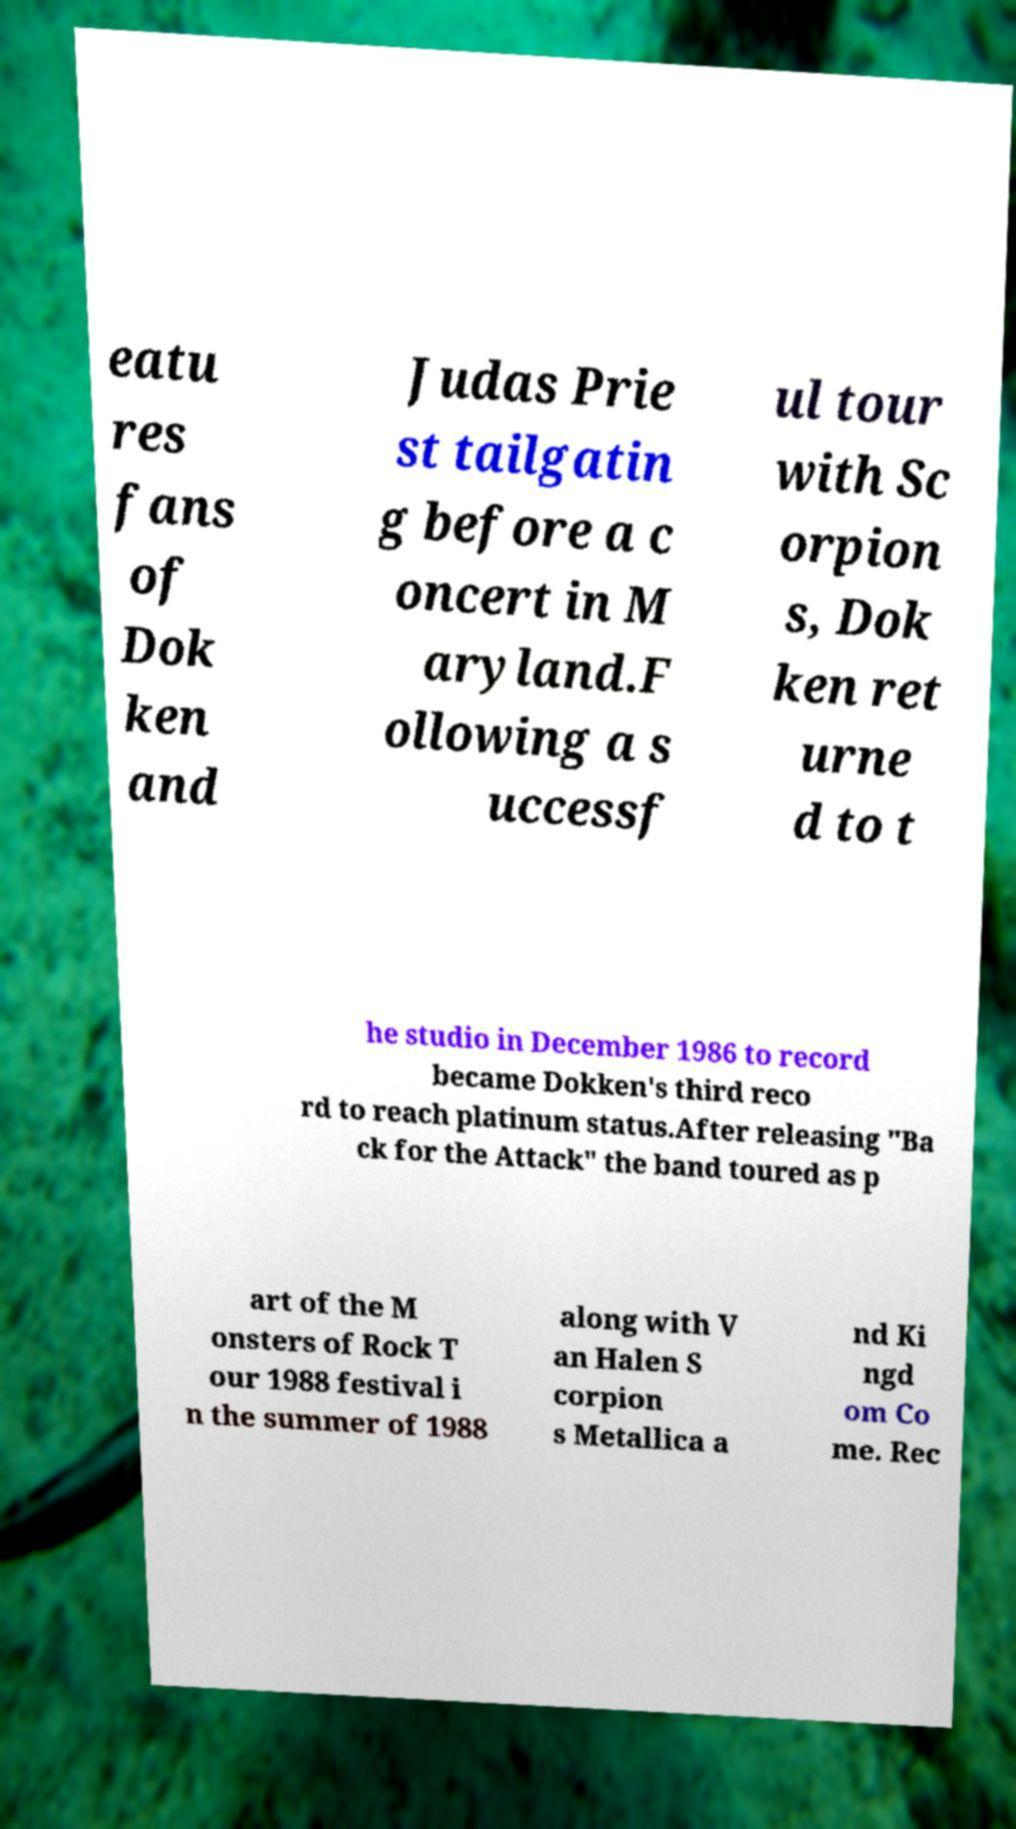There's text embedded in this image that I need extracted. Can you transcribe it verbatim? eatu res fans of Dok ken and Judas Prie st tailgatin g before a c oncert in M aryland.F ollowing a s uccessf ul tour with Sc orpion s, Dok ken ret urne d to t he studio in December 1986 to record became Dokken's third reco rd to reach platinum status.After releasing "Ba ck for the Attack" the band toured as p art of the M onsters of Rock T our 1988 festival i n the summer of 1988 along with V an Halen S corpion s Metallica a nd Ki ngd om Co me. Rec 